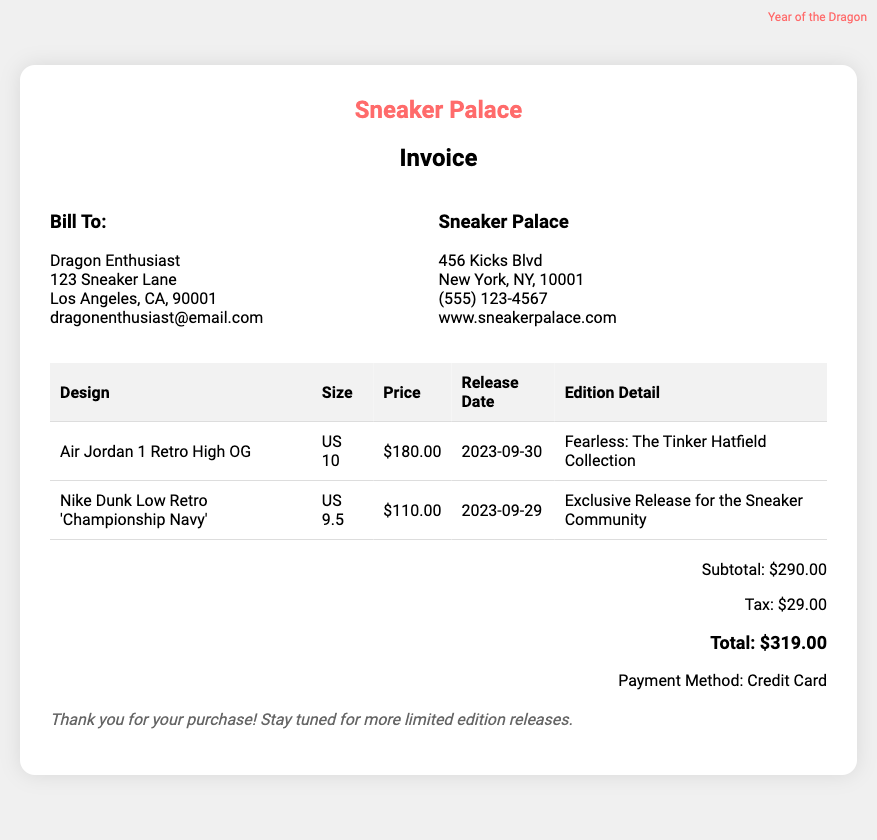What is the total amount due? The total amount due is specified in the document, including the subtotal and tax.
Answer: $319.00 What is the design of the first sneaker? The design of the first sneaker is detailed in the table under the 'Design' column.
Answer: Air Jordan 1 Retro High OG What size is the second sneaker? The size of the second sneaker can be found in the table under the 'Size' column.
Answer: US 9.5 What is the release date of the Air Jordan 1 Retro High OG? The release date is included in the table under the 'Release Date' column for that particular sneaker.
Answer: 2023-09-30 What is the subtotal before tax? The subtotal is listed separately in the total section of the document.
Answer: $290.00 How much tax is included in the total? The tax amount is displayed in the total section.
Answer: $29.00 What is the edition detail of the Nike Dunk Low Retro 'Championship Navy'? The edition detail is available in the table under the 'Edition Detail' column.
Answer: Exclusive Release for the Sneaker Community Who is billed on this invoice? The billing information is shown under the 'Bill To' section of the document.
Answer: Dragon Enthusiast What payment method was used? The payment method is specified in the total section of the invoice.
Answer: Credit Card 